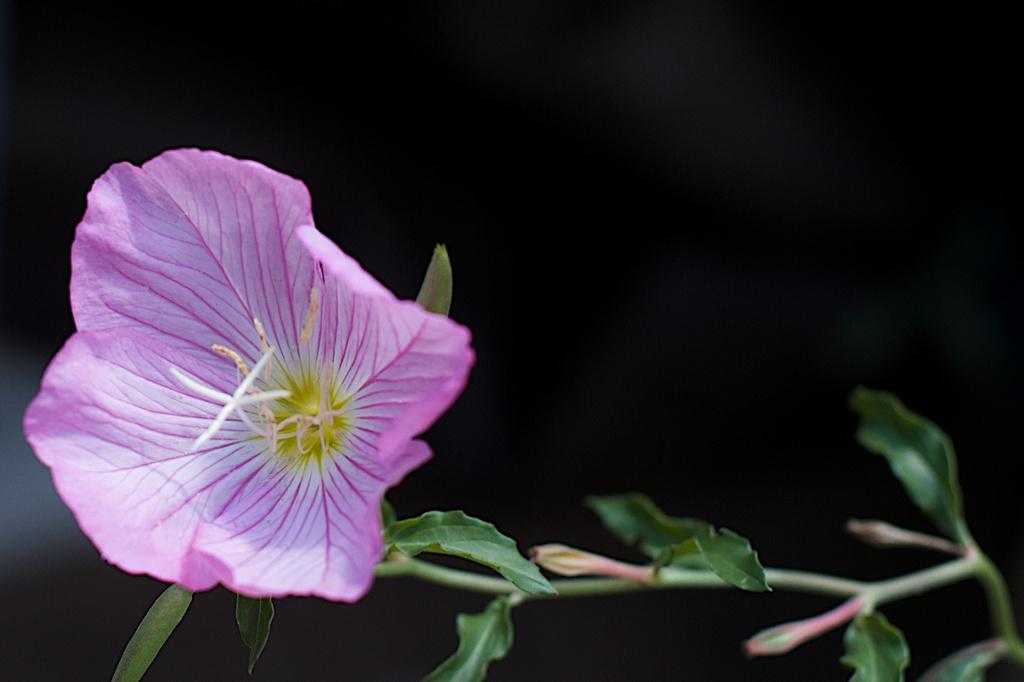What is the main subject of the image? The main subject of the image is a flower. Can you describe the color of the flower? The flower is violet in color. What part of the flower is connected to the stem? There is a stem associated with the flower. Are there any other living organisms present in the image? Yes, there are two bugs attached to the stem. What is the overall color scheme of the image? The backdrop of the image is dark. What type of humor can be seen in the image? There is no humor present in the image; it features a violet flower with a stem and two bugs. Can you tell me how many stations are visible in the image? There are no stations present in the image. 